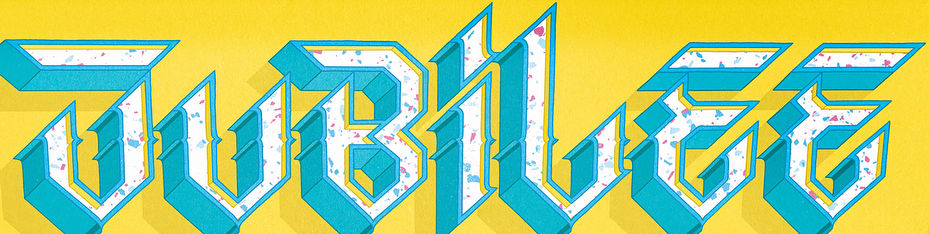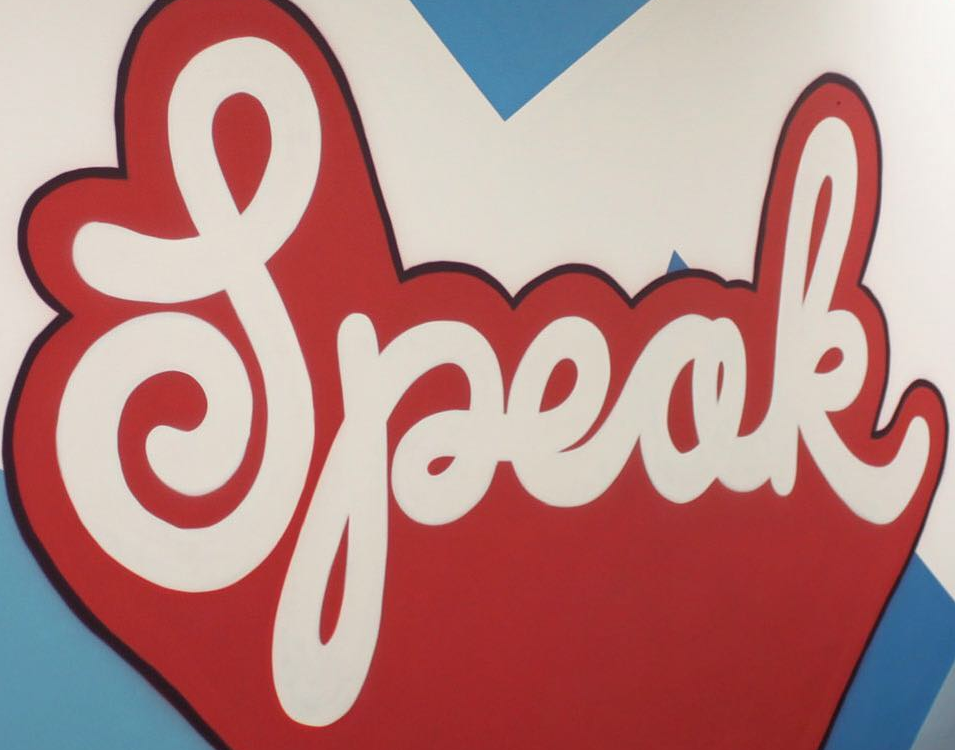Identify the words shown in these images in order, separated by a semicolon. JUBiLEE; Speak 